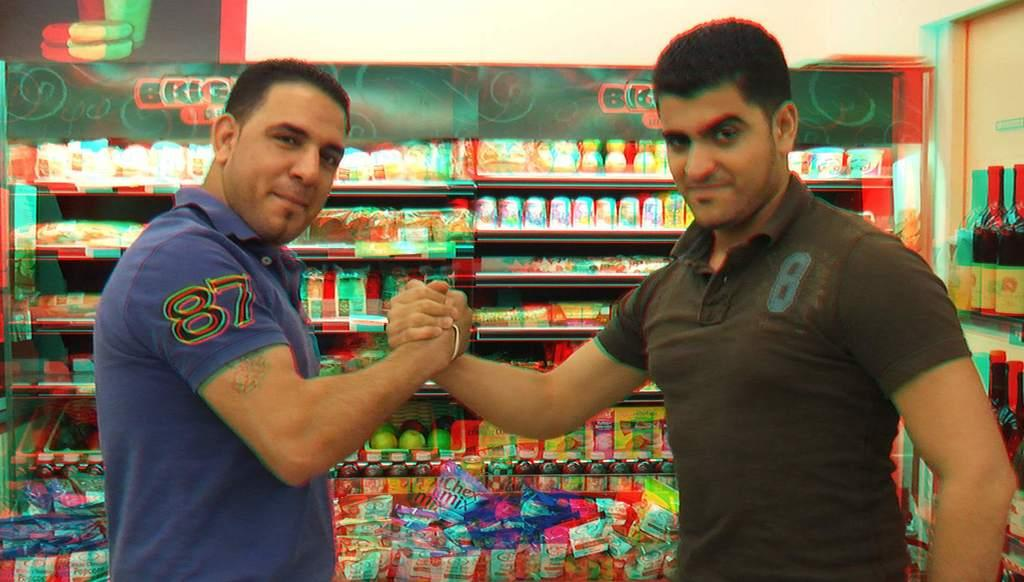<image>
Create a compact narrative representing the image presented. two men wearing shirts with numbers on them, with one being 87 and the other being 8 